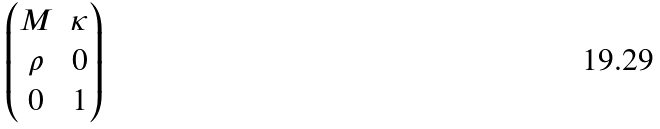<formula> <loc_0><loc_0><loc_500><loc_500>\begin{pmatrix} M & \kappa \\ \rho & 0 \\ 0 & 1 \end{pmatrix}</formula> 